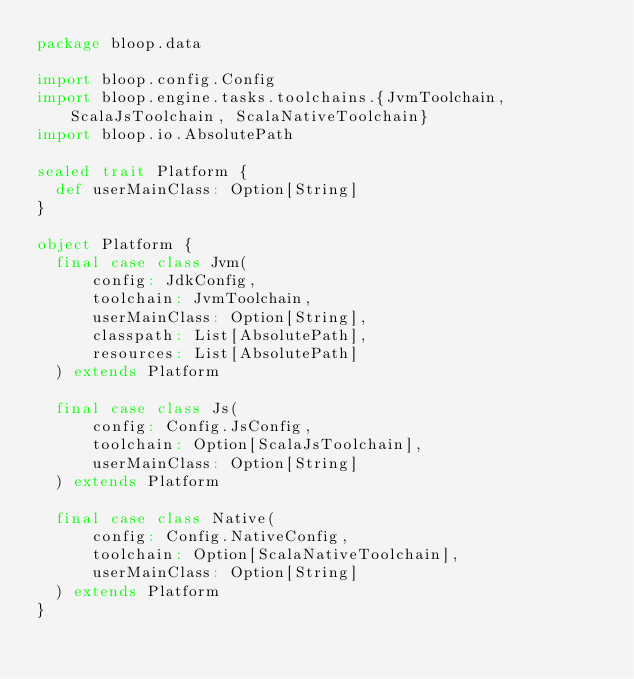<code> <loc_0><loc_0><loc_500><loc_500><_Scala_>package bloop.data

import bloop.config.Config
import bloop.engine.tasks.toolchains.{JvmToolchain, ScalaJsToolchain, ScalaNativeToolchain}
import bloop.io.AbsolutePath

sealed trait Platform {
  def userMainClass: Option[String]
}

object Platform {
  final case class Jvm(
      config: JdkConfig,
      toolchain: JvmToolchain,
      userMainClass: Option[String],
      classpath: List[AbsolutePath],
      resources: List[AbsolutePath]
  ) extends Platform

  final case class Js(
      config: Config.JsConfig,
      toolchain: Option[ScalaJsToolchain],
      userMainClass: Option[String]
  ) extends Platform

  final case class Native(
      config: Config.NativeConfig,
      toolchain: Option[ScalaNativeToolchain],
      userMainClass: Option[String]
  ) extends Platform
}
</code> 